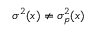<formula> <loc_0><loc_0><loc_500><loc_500>\sigma ^ { 2 } ( x ) \neq \sigma _ { p } ^ { 2 } ( x )</formula> 